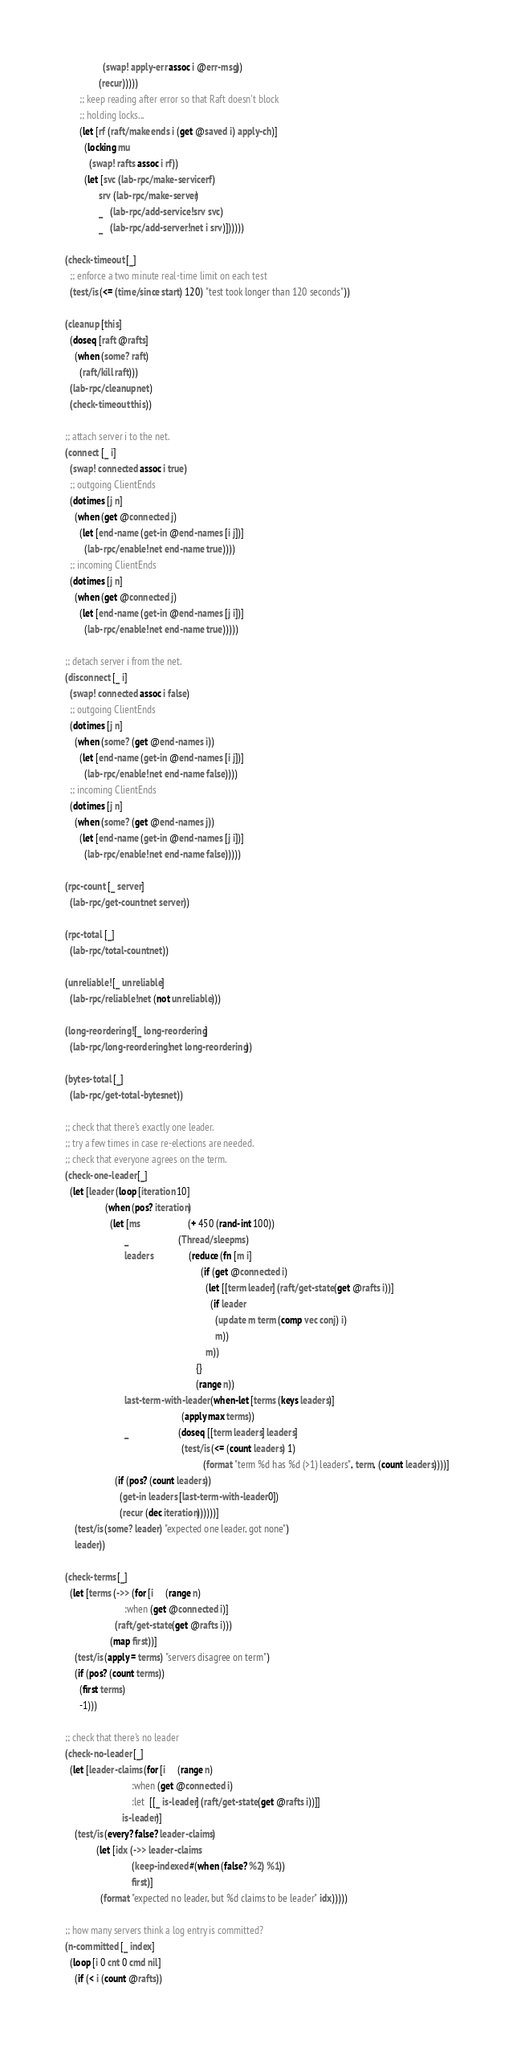<code> <loc_0><loc_0><loc_500><loc_500><_Clojure_>                  (swap! apply-err assoc i @err-msg))
                (recur)))))
        ;; keep reading after error so that Raft doesn't block
        ;; holding locks...
        (let [rf (raft/make ends i (get @saved i) apply-ch)]
          (locking mu
            (swap! rafts assoc i rf))
          (let [svc (lab-rpc/make-service rf)
                srv (lab-rpc/make-server)
                _   (lab-rpc/add-service! srv svc)
                _   (lab-rpc/add-server! net i srv)])))))

  (check-timeout [_]
    ;; enforce a two minute real-time limit on each test
    (test/is (<= (time/since start) 120) "test took longer than 120 seconds"))

  (cleanup [this]
    (doseq [raft @rafts]
      (when (some? raft)
        (raft/kill raft)))
    (lab-rpc/cleanup net)
    (check-timeout this))

  ;; attach server i to the net.
  (connect [_ i]
    (swap! connected assoc i true)
    ;; outgoing ClientEnds
    (dotimes [j n]
      (when (get @connected j)
        (let [end-name (get-in @end-names [i j])]
          (lab-rpc/enable! net end-name true))))
    ;; incoming ClientEnds
    (dotimes [j n]
      (when (get @connected j)
        (let [end-name (get-in @end-names [j i])]
          (lab-rpc/enable! net end-name true)))))

  ;; detach server i from the net.
  (disconnect [_ i]
    (swap! connected assoc i false)
    ;; outgoing ClientEnds
    (dotimes [j n]
      (when (some? (get @end-names i))
        (let [end-name (get-in @end-names [i j])]
          (lab-rpc/enable! net end-name false))))
    ;; incoming ClientEnds
    (dotimes [j n]
      (when (some? (get @end-names j))
        (let [end-name (get-in @end-names [j i])]
          (lab-rpc/enable! net end-name false)))))

  (rpc-count [_ server]
    (lab-rpc/get-count net server))

  (rpc-total [_]
    (lab-rpc/total-count net))

  (unreliable! [_ unreliable]
    (lab-rpc/reliable! net (not unreliable)))

  (long-reordering! [_ long-reordering]
    (lab-rpc/long-reordering! net long-reordering))

  (bytes-total [_]
    (lab-rpc/get-total-bytes net))

  ;; check that there's exactly one leader.
  ;; try a few times in case re-elections are needed.
  ;; check that everyone agrees on the term.
  (check-one-leader [_]
    (let [leader (loop [iteration 10]
                   (when (pos? iteration)
                     (let [ms                    (+ 450 (rand-int 100))
                           _                     (Thread/sleep ms)
                           leaders               (reduce (fn [m i]
                                                           (if (get @connected i)
                                                             (let [[term leader] (raft/get-state (get @rafts i))]
                                                               (if leader
                                                                 (update m term (comp vec conj) i)
                                                                 m))
                                                             m))
                                                         {}
                                                         (range n))
                           last-term-with-leader (when-let [terms (keys leaders)]
                                                   (apply max terms))
                           _                     (doseq [[term leaders] leaders]
                                                   (test/is (<= (count leaders) 1)
                                                            (format "term %d has %d (>1) leaders", term, (count leaders))))]
                       (if (pos? (count leaders))
                         (get-in leaders [last-term-with-leader 0])
                         (recur (dec iteration))))))]
      (test/is (some? leader) "expected one leader, got none")
      leader))

  (check-terms [_]
    (let [terms (->> (for [i     (range n)
                           :when (get @connected i)]
                       (raft/get-state (get @rafts i)))
                     (map first))]
      (test/is (apply = terms) "servers disagree on term")
      (if (pos? (count terms))
        (first terms)
        -1)))

  ;; check that there's no leader
  (check-no-leader [_]
    (let [leader-claims (for [i     (range n)
                              :when (get @connected i)
                              :let  [[_ is-leader] (raft/get-state (get @rafts i))]]
                          is-leader)]
      (test/is (every? false? leader-claims)
               (let [idx (->> leader-claims
                              (keep-indexed #(when (false? %2) %1))
                              first)]
                 (format "expected no leader, but %d claims to be leader" idx)))))

  ;; how many servers think a log entry is committed?
  (n-committed [_ index]
    (loop [i 0 cnt 0 cmd nil]
      (if (< i (count @rafts))</code> 